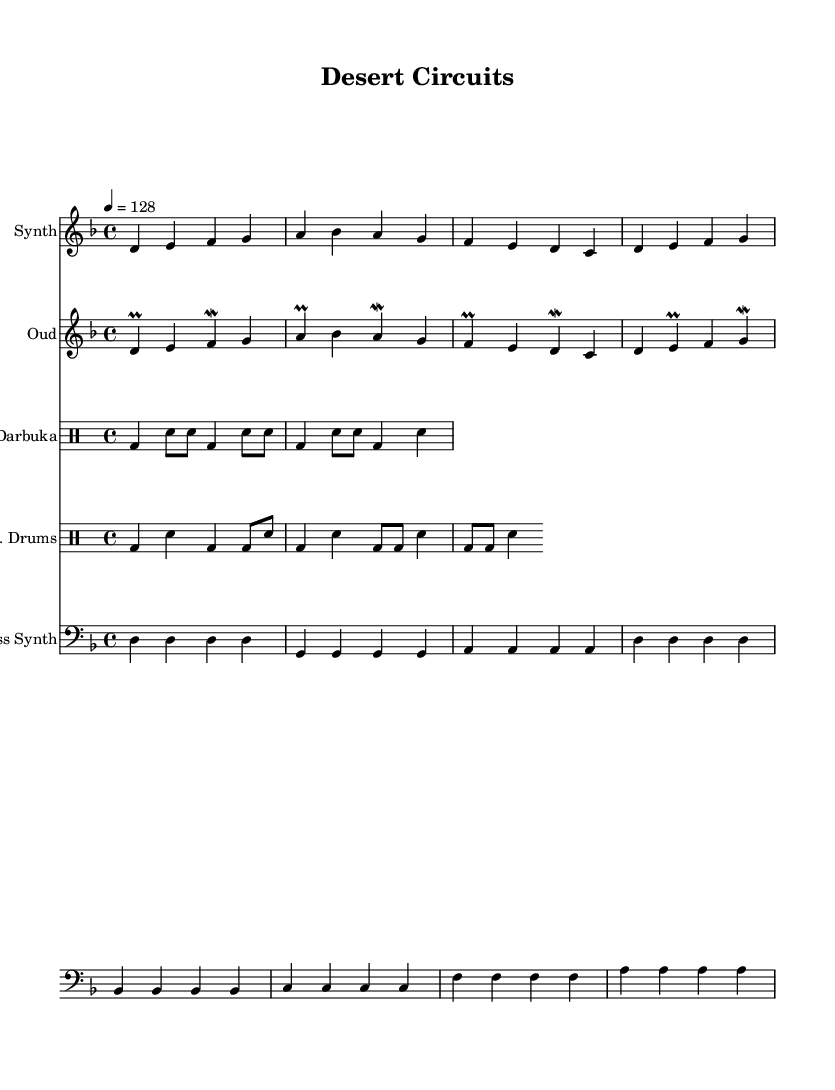What is the key signature of this music? The key signature is D minor, which has one flat (B flat). The music displays one flat in the key signature section, confirming it is D minor.
Answer: D minor What is the time signature of this music? The time signature is 4/4, as noted at the beginning of the score. You can identify this by looking for the notation indicating four beats per measure.
Answer: 4/4 What is the tempo marking for this piece? The tempo is set at 128 beats per minute, as indicated in the score. It specifies "4 = 128," meaning the quarter note receives 128 beats per minute.
Answer: 128 How many measures are in the synth melody? The synth melody contains four measures. You can count the vertical lines separating the measures to determine the number of measures.
Answer: 4 Which instrument has a mordent in its part? The oud part contains mordents, as seen in several notes such as the fourth note in the first measure. A mordent is a specific ornamental note indicating a rapid alternation between a note and a note a step below.
Answer: Oud What type of drums create a rhythm pattern along with the darbuka? The electronic drums accompany the darbuka, as indicated in the score with the label "E. Drums" beneath one of the drum staff sections.
Answer: Electronic drums What is the fundamental note for the bass synth throughout the first measure? The fundamental note for the bass synth is D. The first measure consists entirely of D notes, confirming it as the fundamental note played.
Answer: D 